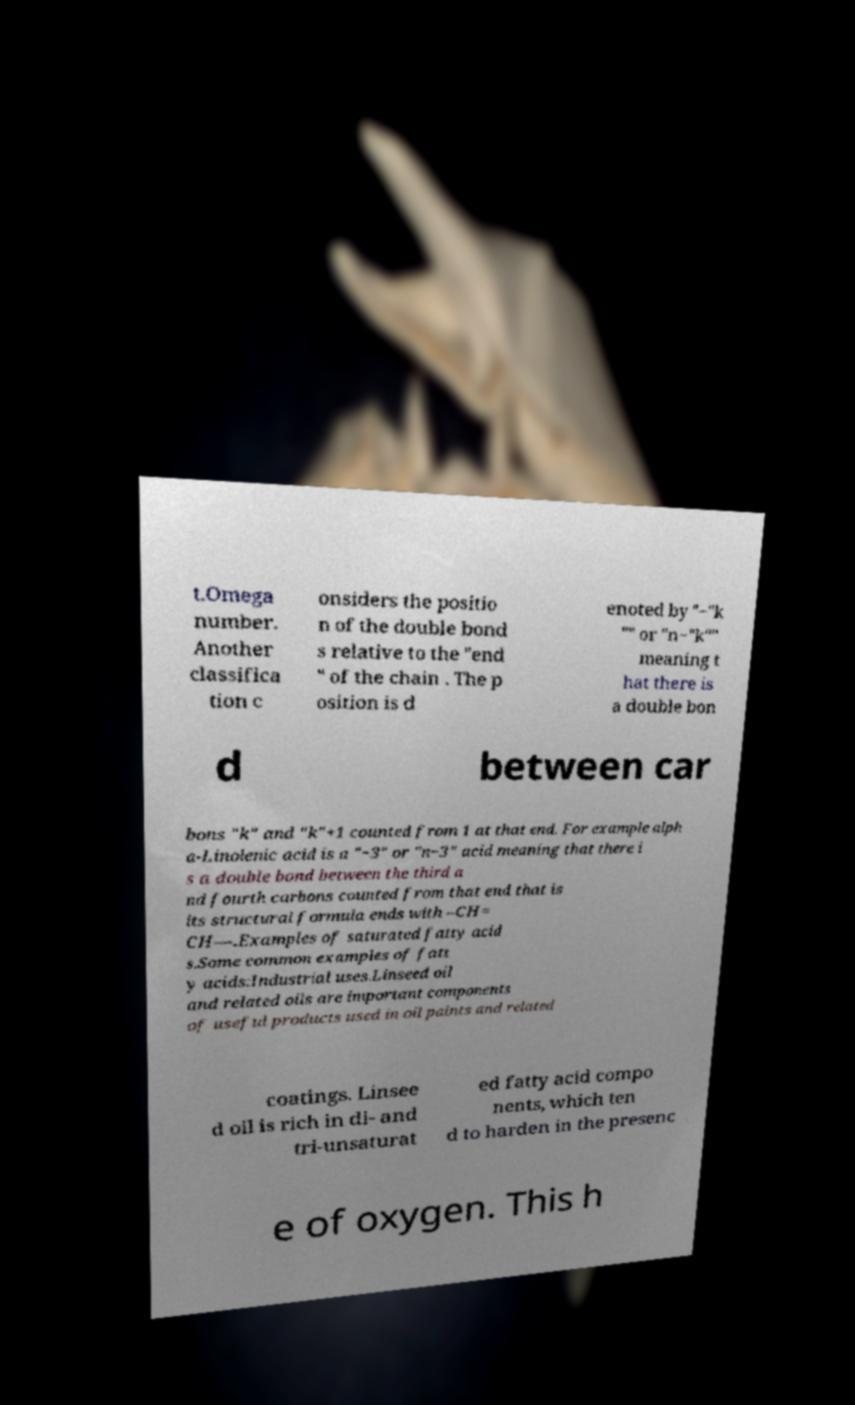Can you read and provide the text displayed in the image?This photo seems to have some interesting text. Can you extract and type it out for me? t.Omega number. Another classifica tion c onsiders the positio n of the double bond s relative to the "end " of the chain . The p osition is d enoted by "−"k "" or "n−"k"" meaning t hat there is a double bon d between car bons "k" and "k"+1 counted from 1 at that end. For example alph a-Linolenic acid is a "−3" or "n−3" acid meaning that there i s a double bond between the third a nd fourth carbons counted from that end that is its structural formula ends with –CH= CH––.Examples of saturated fatty acid s.Some common examples of fatt y acids:Industrial uses.Linseed oil and related oils are important components of useful products used in oil paints and related coatings. Linsee d oil is rich in di- and tri-unsaturat ed fatty acid compo nents, which ten d to harden in the presenc e of oxygen. This h 